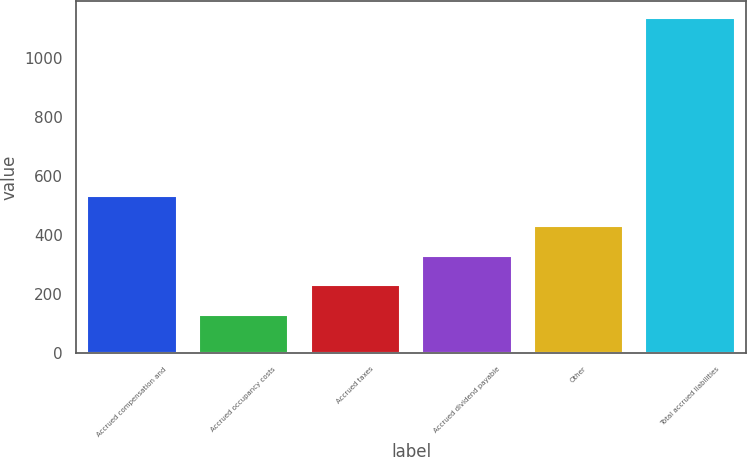<chart> <loc_0><loc_0><loc_500><loc_500><bar_chart><fcel>Accrued compensation and<fcel>Accrued occupancy costs<fcel>Accrued taxes<fcel>Accrued dividend payable<fcel>Other<fcel>Total accrued liabilities<nl><fcel>529.66<fcel>126.9<fcel>227.59<fcel>328.28<fcel>428.97<fcel>1133.8<nl></chart> 